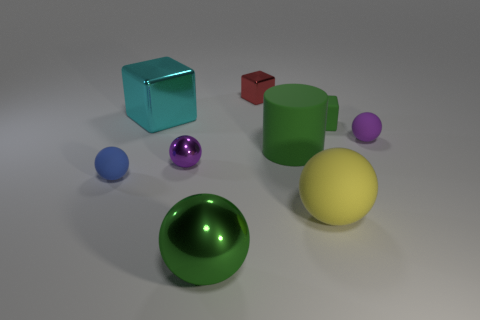What is the large cyan cube made of?
Ensure brevity in your answer.  Metal. How many other objects are there of the same size as the rubber cylinder?
Give a very brief answer. 3. There is a green thing in front of the big matte cylinder; how big is it?
Offer a terse response. Large. There is a big object that is left of the small purple ball that is left of the matte thing that is behind the purple matte ball; what is it made of?
Your answer should be compact. Metal. Is the shape of the red shiny object the same as the large cyan shiny object?
Ensure brevity in your answer.  Yes. How many rubber things are red cubes or purple things?
Offer a very short reply. 1. How many things are there?
Offer a terse response. 9. There is a metallic ball that is the same size as the yellow rubber thing; what color is it?
Offer a very short reply. Green. Does the red metal thing have the same size as the purple shiny sphere?
Offer a very short reply. Yes. There is a matte object that is the same color as the cylinder; what is its shape?
Offer a terse response. Cube. 